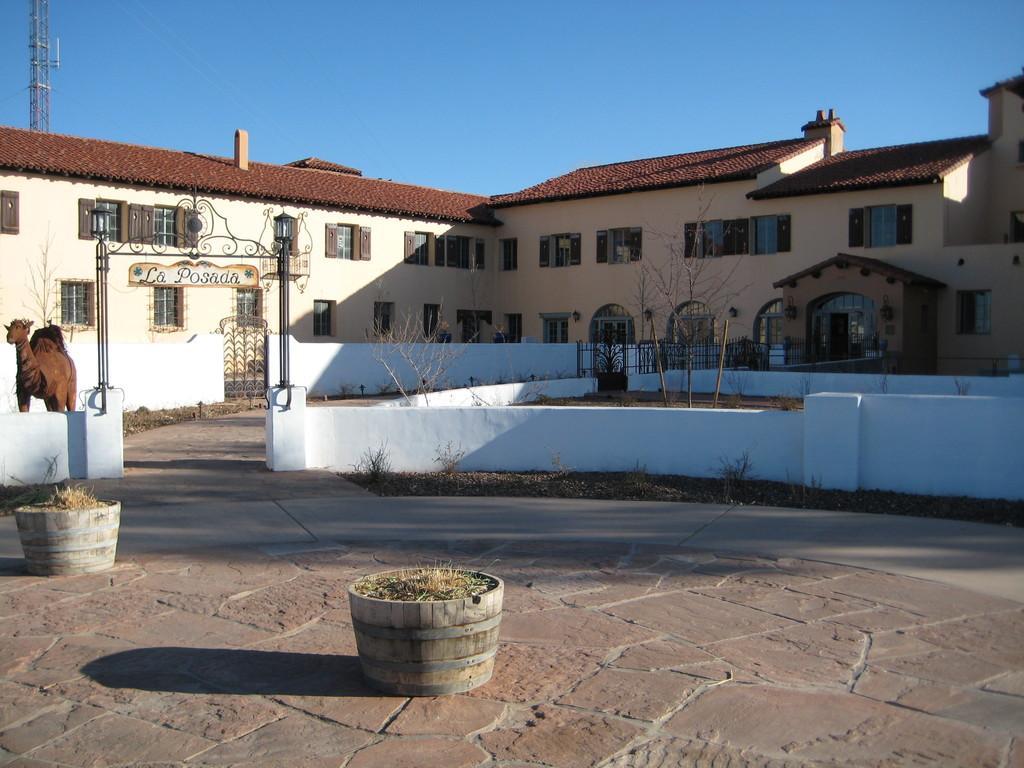Describe this image in one or two sentences. This picture shows a building and we see couple of trees and we see a camel and a name board and we see a tower and a blue sky. 